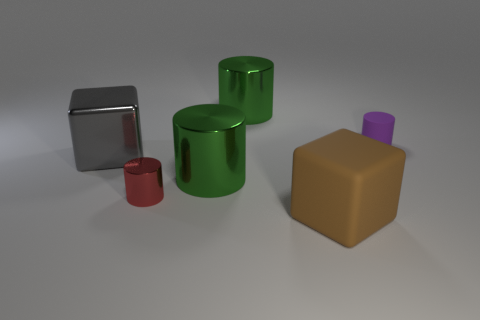Subtract 1 cylinders. How many cylinders are left? 3 Add 3 brown objects. How many objects exist? 9 Subtract all cylinders. How many objects are left? 2 Add 3 purple objects. How many purple objects are left? 4 Add 5 gray blocks. How many gray blocks exist? 6 Subtract 0 yellow balls. How many objects are left? 6 Subtract all big green things. Subtract all big cubes. How many objects are left? 2 